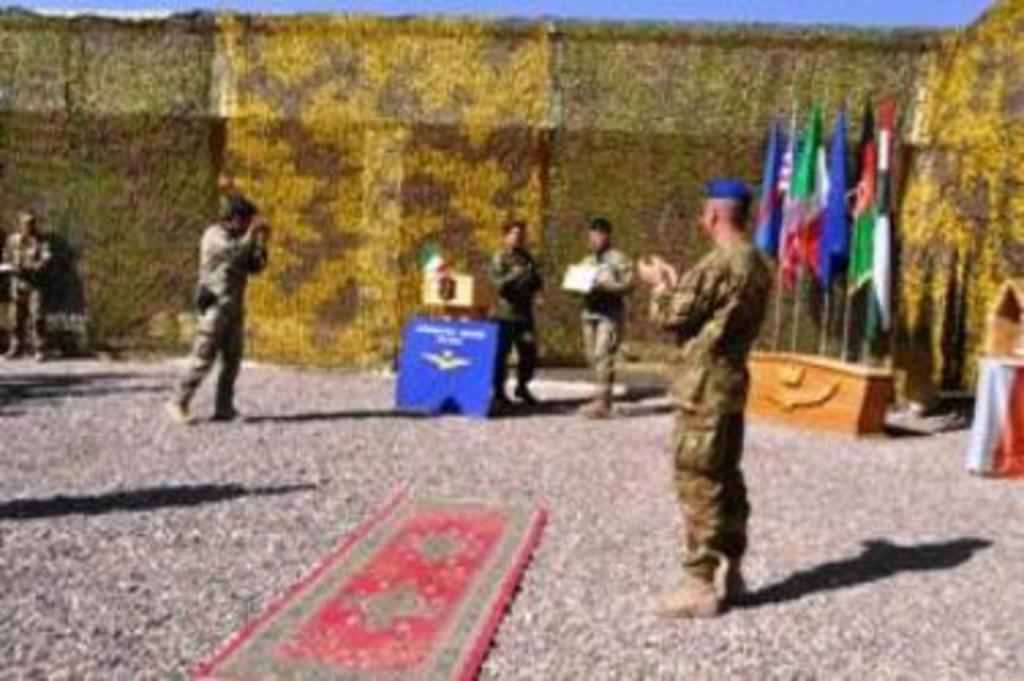Can you describe this image briefly? There is a mat on the floor and a person standing in the foreground area of the image, there are flags, people, it seems like a curtain and the sky in the background. 